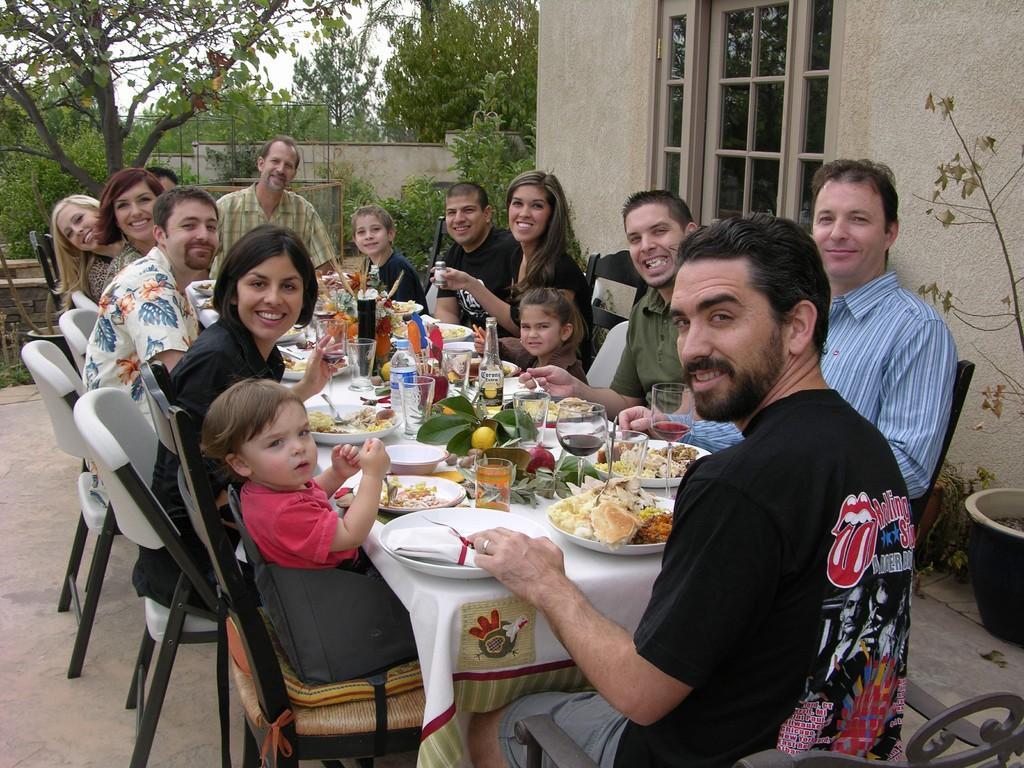Please provide a concise description of this image. In this image I see a number of people who are sitting on the chairs and there is table in front of them and there is lot of food in the plates and glasses on it. In the background I can see the wall, a window, few plants and the trees. 